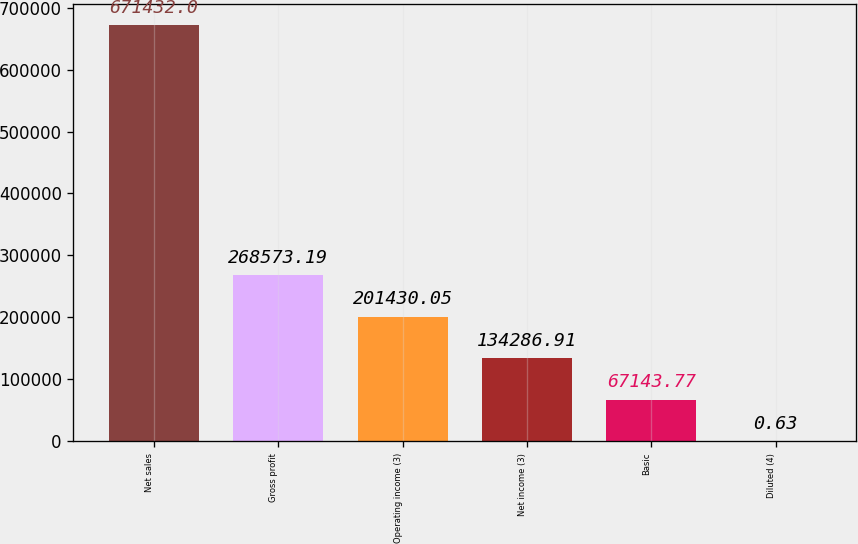Convert chart. <chart><loc_0><loc_0><loc_500><loc_500><bar_chart><fcel>Net sales<fcel>Gross profit<fcel>Operating income (3)<fcel>Net income (3)<fcel>Basic<fcel>Diluted (4)<nl><fcel>671432<fcel>268573<fcel>201430<fcel>134287<fcel>67143.8<fcel>0.63<nl></chart> 